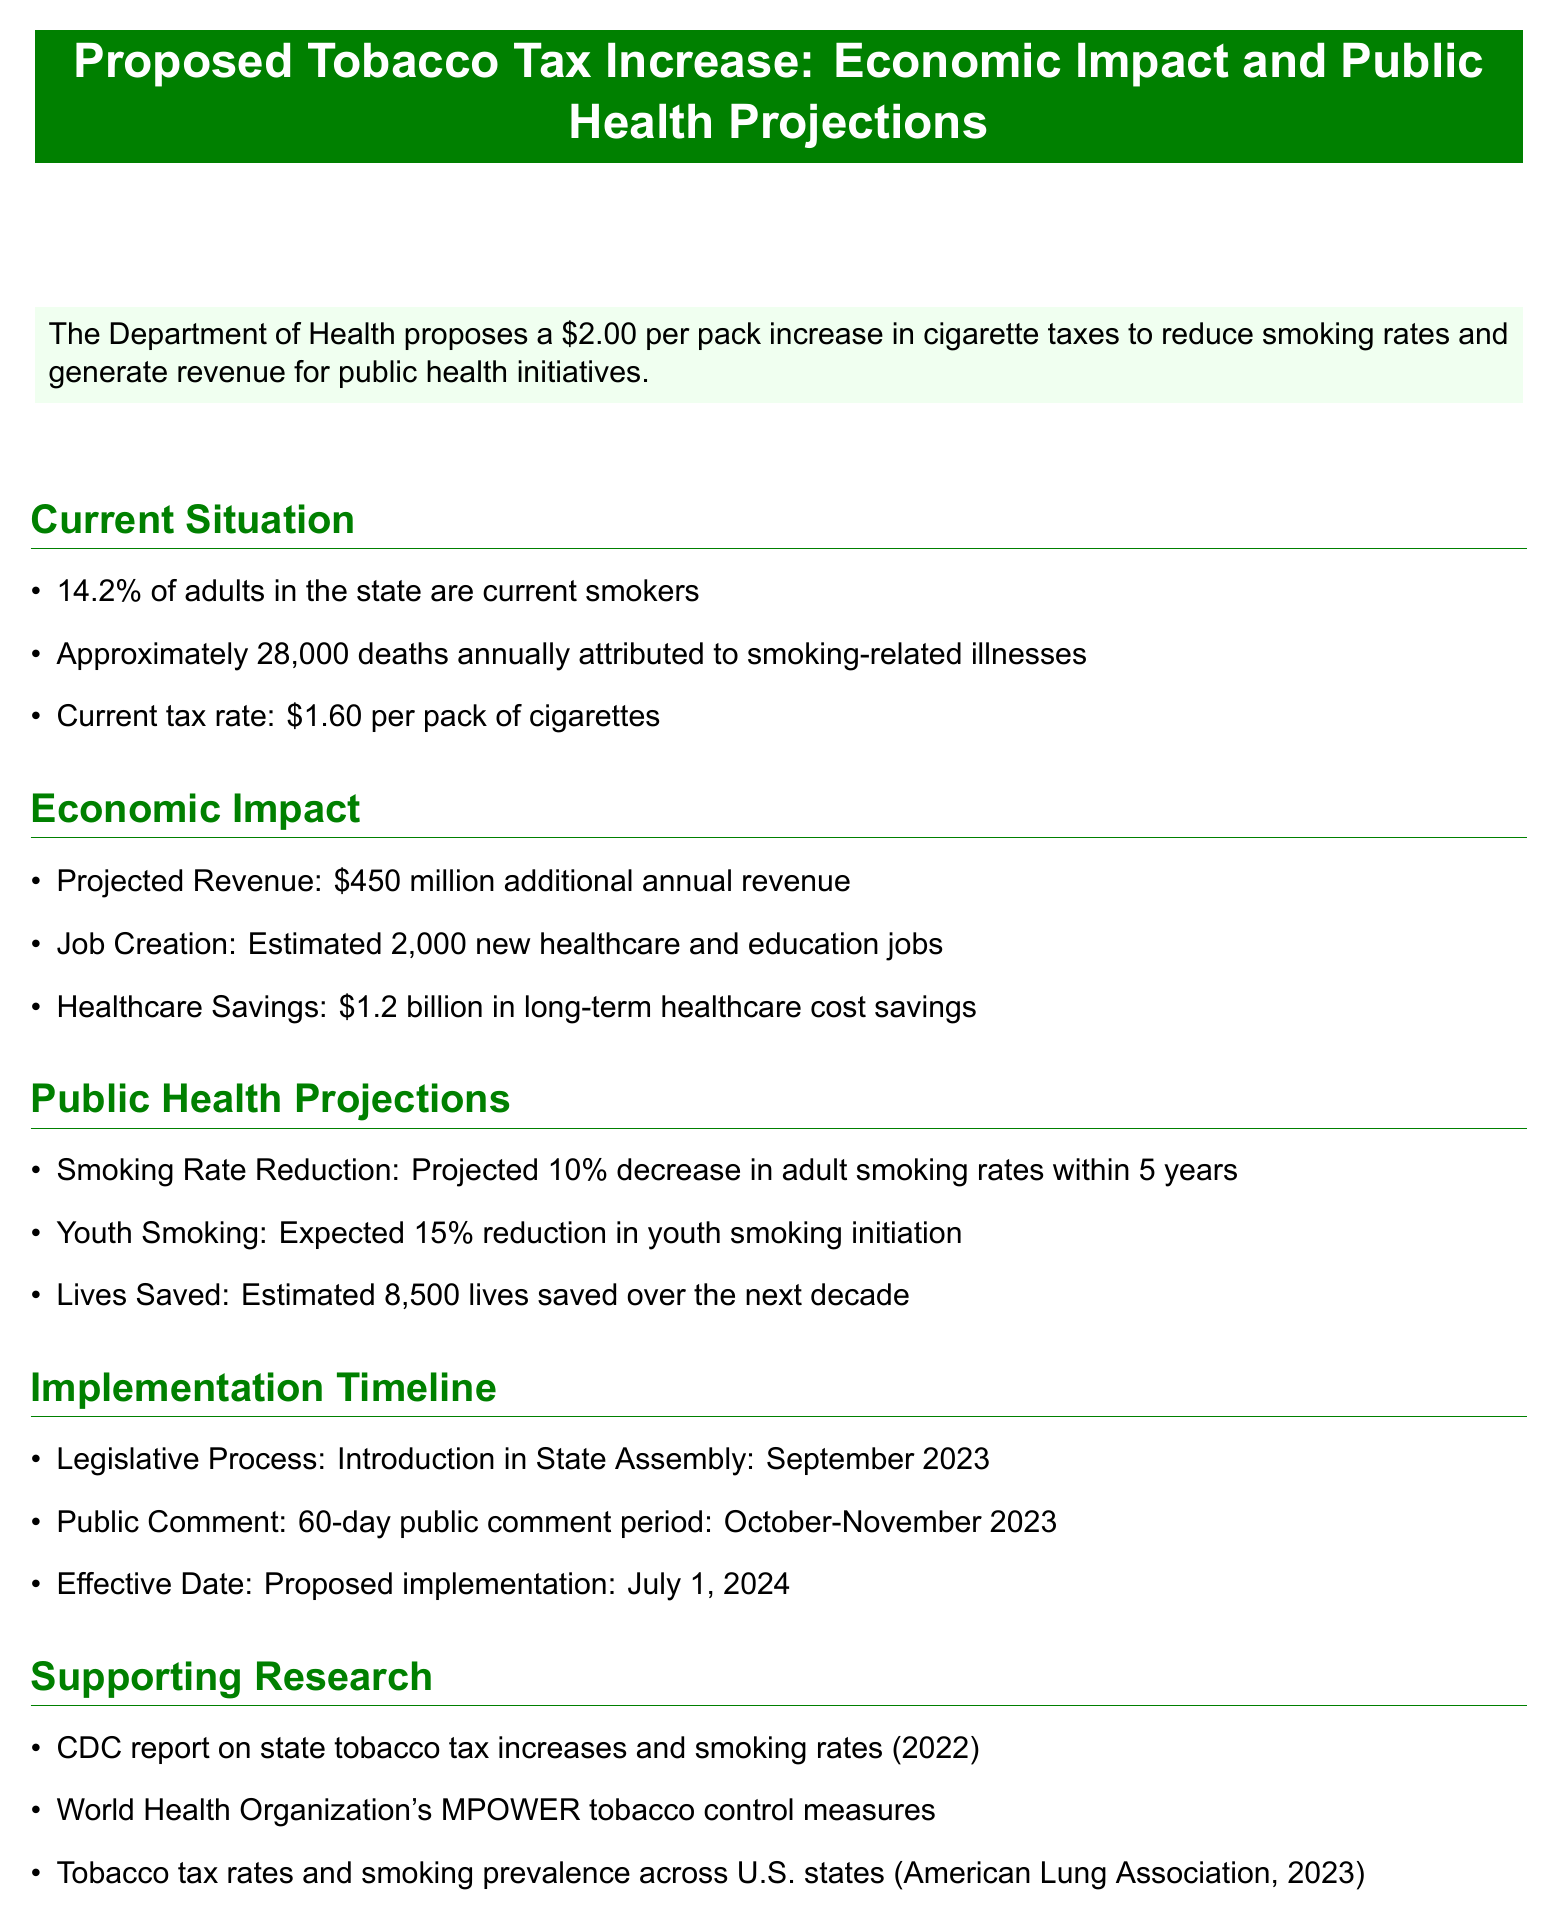What is the proposed increase in cigarette tax? The proposed increase in cigarette tax is outlined in the executive summary of the document.
Answer: $2.00 What is the current smoking rate among adults? The document states the current smoking rate among adults in the state.
Answer: 14.2% How many deaths are attributed to smoking-related illnesses annually? The number of deaths attributed to smoking-related illnesses is provided in the current situation section of the document.
Answer: 28,000 What is the projected annual revenue from the tax increase? The projected annual revenue is detailed in the economic impact section of the document.
Answer: $450 million What is the expected reduction in youth smoking initiation? The expected reduction in youth smoking initiation is mentioned in the public health projections section.
Answer: 15% How many lives are estimated to be saved over the next decade? The estimated number of lives saved is stated in the public health projections.
Answer: 8,500 When is the proposed implementation date for the tax increase? The proposed implementation date is found under the implementation timeline section of the document.
Answer: July 1, 2024 How many new jobs are expected to be created? The number of new jobs expected to be created is included in the economic impact section.
Answer: 2,000 What is the length of the public comment period? The length of the public comment period is specified in the implementation timeline.
Answer: 60 days 